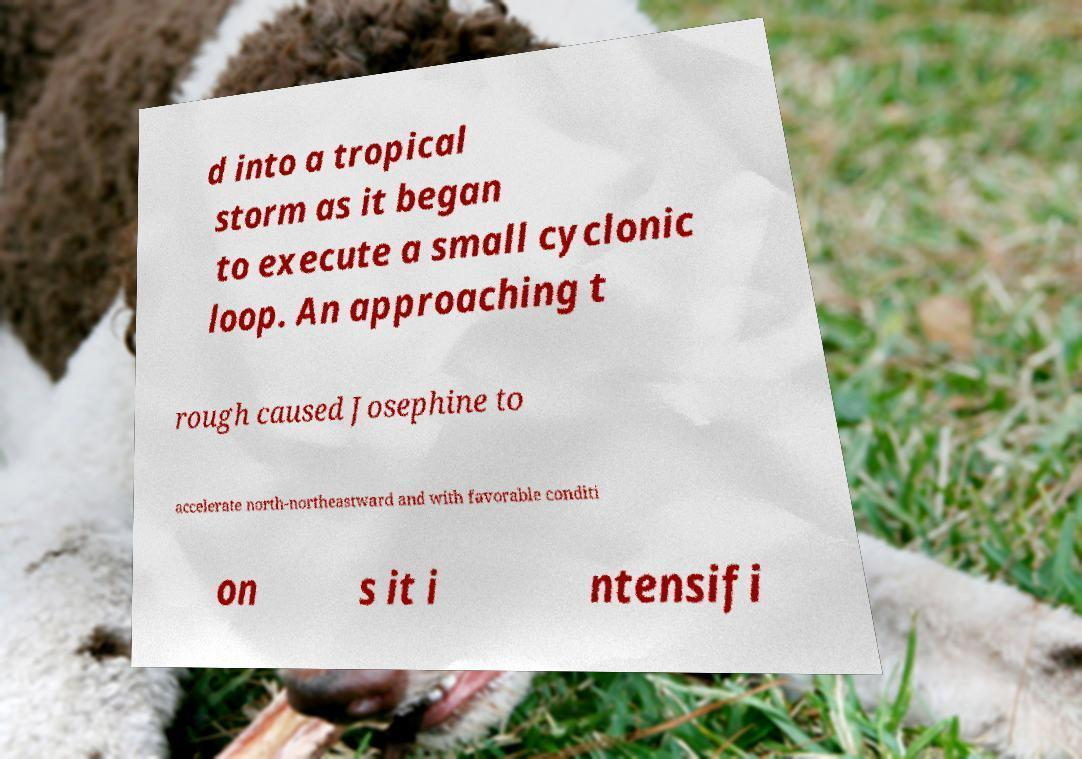Please read and relay the text visible in this image. What does it say? d into a tropical storm as it began to execute a small cyclonic loop. An approaching t rough caused Josephine to accelerate north-northeastward and with favorable conditi on s it i ntensifi 